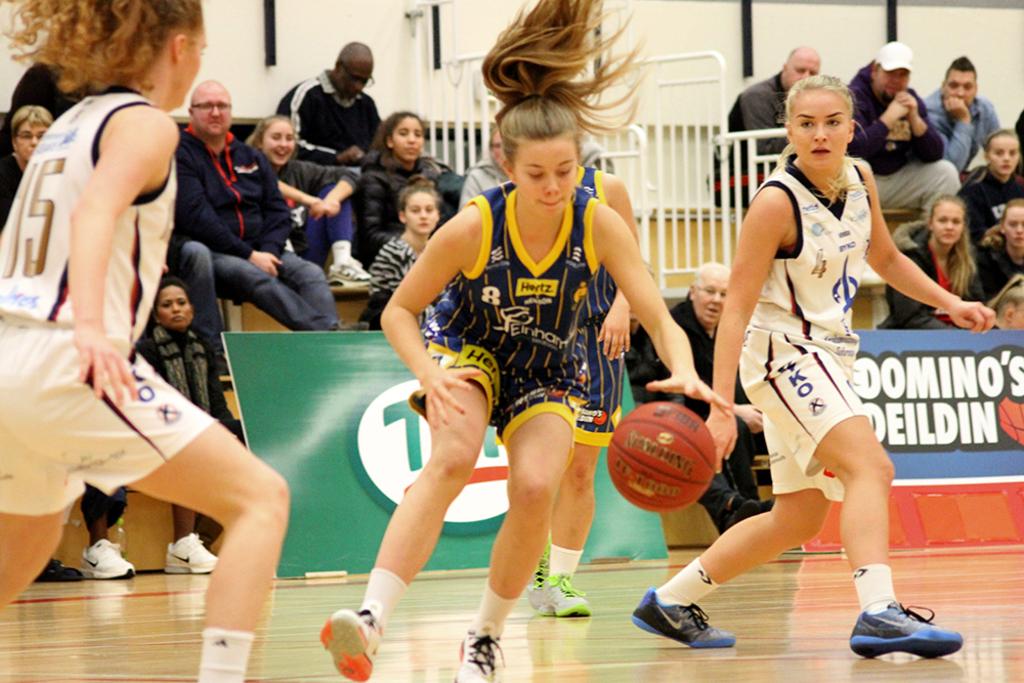What is the jersey number of the girl on the left?
Your response must be concise. 15. 